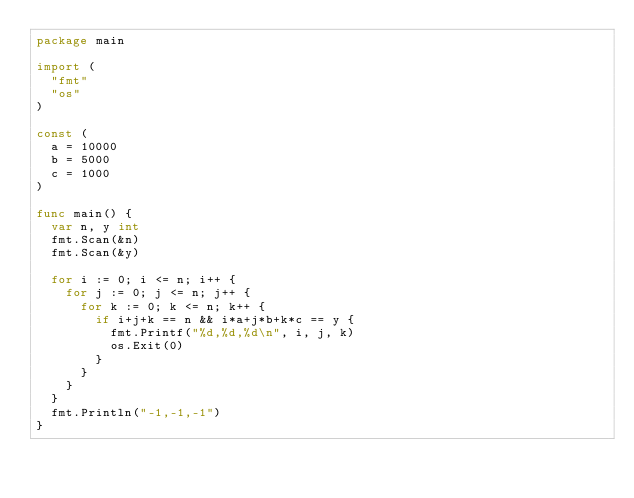<code> <loc_0><loc_0><loc_500><loc_500><_Go_>package main

import (
	"fmt"
	"os"
)

const (
	a = 10000
	b = 5000
	c = 1000
)

func main() {
	var n, y int
	fmt.Scan(&n)
	fmt.Scan(&y)

	for i := 0; i <= n; i++ {
		for j := 0; j <= n; j++ {
			for k := 0; k <= n; k++ {
				if i+j+k == n && i*a+j*b+k*c == y {
					fmt.Printf("%d,%d,%d\n", i, j, k)
					os.Exit(0)
				}
			}
		}
	}
	fmt.Println("-1,-1,-1")
}
</code> 